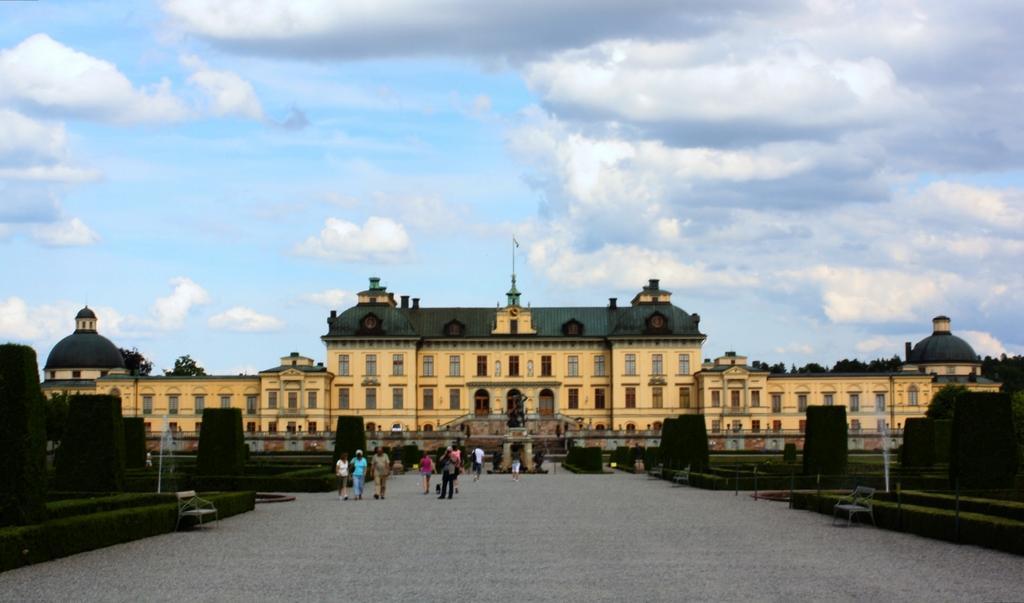Can you describe this image briefly? In the middle of the image we can see some people are walking and standing and there are some benches and plants. In the middle of the image there is a building. Behind the building there are some trees. At the top of the image there are some clouds in the sky. 